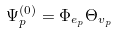<formula> <loc_0><loc_0><loc_500><loc_500>\Psi _ { p } ^ { ( 0 ) } = \Phi _ { e _ { p } } \Theta _ { v _ { p } }</formula> 